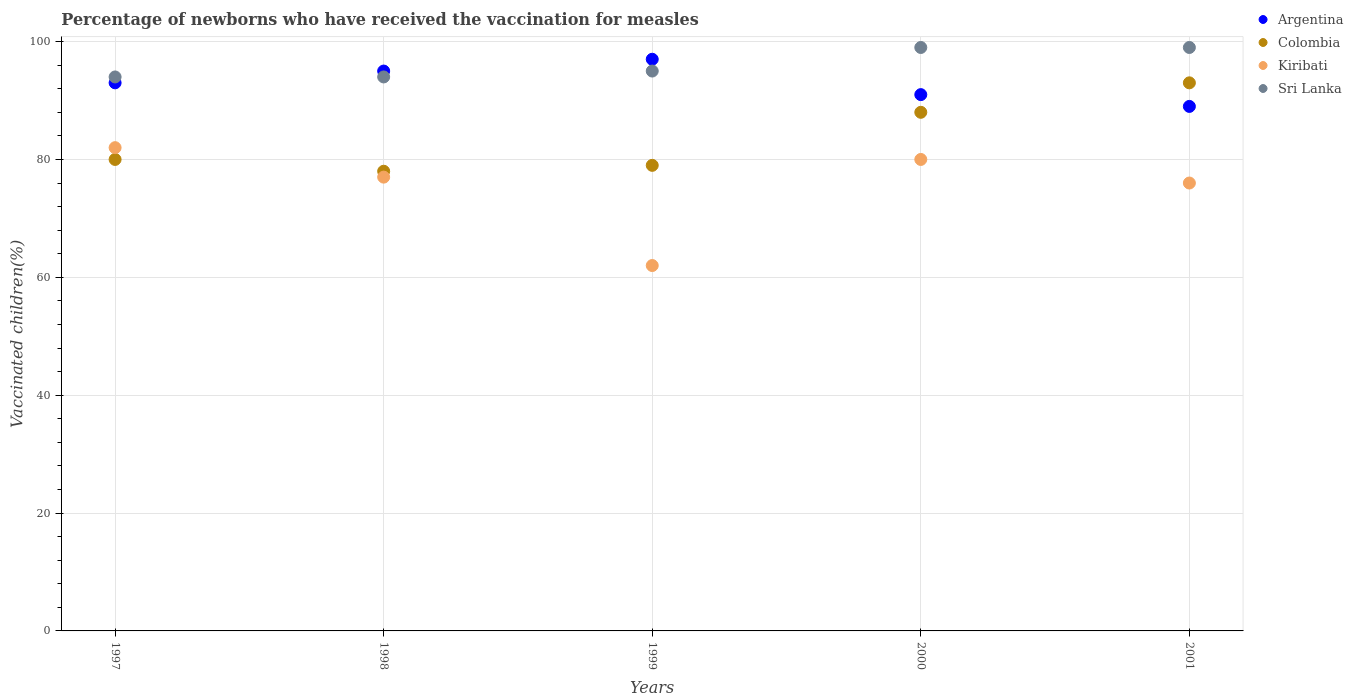What is the percentage of vaccinated children in Colombia in 2000?
Give a very brief answer. 88. Across all years, what is the maximum percentage of vaccinated children in Colombia?
Ensure brevity in your answer.  93. Across all years, what is the minimum percentage of vaccinated children in Argentina?
Make the answer very short. 89. In which year was the percentage of vaccinated children in Argentina minimum?
Offer a terse response. 2001. What is the total percentage of vaccinated children in Sri Lanka in the graph?
Keep it short and to the point. 481. What is the difference between the percentage of vaccinated children in Colombia in 1997 and that in 2001?
Your answer should be very brief. -13. What is the average percentage of vaccinated children in Sri Lanka per year?
Offer a very short reply. 96.2. In the year 2001, what is the difference between the percentage of vaccinated children in Sri Lanka and percentage of vaccinated children in Kiribati?
Offer a terse response. 23. In how many years, is the percentage of vaccinated children in Kiribati greater than 48 %?
Make the answer very short. 5. What is the ratio of the percentage of vaccinated children in Sri Lanka in 1997 to that in 1999?
Keep it short and to the point. 0.99. Is the percentage of vaccinated children in Sri Lanka in 1997 less than that in 2000?
Give a very brief answer. Yes. Is the difference between the percentage of vaccinated children in Sri Lanka in 1997 and 1998 greater than the difference between the percentage of vaccinated children in Kiribati in 1997 and 1998?
Keep it short and to the point. No. What is the difference between the highest and the lowest percentage of vaccinated children in Sri Lanka?
Your answer should be compact. 5. In how many years, is the percentage of vaccinated children in Argentina greater than the average percentage of vaccinated children in Argentina taken over all years?
Offer a very short reply. 2. Is it the case that in every year, the sum of the percentage of vaccinated children in Sri Lanka and percentage of vaccinated children in Kiribati  is greater than the sum of percentage of vaccinated children in Argentina and percentage of vaccinated children in Colombia?
Make the answer very short. No. Is it the case that in every year, the sum of the percentage of vaccinated children in Kiribati and percentage of vaccinated children in Argentina  is greater than the percentage of vaccinated children in Colombia?
Your answer should be very brief. Yes. Does the percentage of vaccinated children in Colombia monotonically increase over the years?
Give a very brief answer. No. Is the percentage of vaccinated children in Argentina strictly greater than the percentage of vaccinated children in Colombia over the years?
Provide a succinct answer. No. Is the percentage of vaccinated children in Kiribati strictly less than the percentage of vaccinated children in Argentina over the years?
Keep it short and to the point. Yes. How many years are there in the graph?
Provide a short and direct response. 5. What is the difference between two consecutive major ticks on the Y-axis?
Keep it short and to the point. 20. Does the graph contain any zero values?
Your answer should be compact. No. Does the graph contain grids?
Offer a very short reply. Yes. Where does the legend appear in the graph?
Keep it short and to the point. Top right. How many legend labels are there?
Offer a very short reply. 4. How are the legend labels stacked?
Give a very brief answer. Vertical. What is the title of the graph?
Offer a terse response. Percentage of newborns who have received the vaccination for measles. What is the label or title of the X-axis?
Offer a terse response. Years. What is the label or title of the Y-axis?
Offer a terse response. Vaccinated children(%). What is the Vaccinated children(%) of Argentina in 1997?
Keep it short and to the point. 93. What is the Vaccinated children(%) in Kiribati in 1997?
Your answer should be compact. 82. What is the Vaccinated children(%) in Sri Lanka in 1997?
Provide a succinct answer. 94. What is the Vaccinated children(%) of Sri Lanka in 1998?
Make the answer very short. 94. What is the Vaccinated children(%) in Argentina in 1999?
Provide a succinct answer. 97. What is the Vaccinated children(%) in Colombia in 1999?
Offer a very short reply. 79. What is the Vaccinated children(%) in Kiribati in 1999?
Offer a very short reply. 62. What is the Vaccinated children(%) in Sri Lanka in 1999?
Provide a short and direct response. 95. What is the Vaccinated children(%) of Argentina in 2000?
Make the answer very short. 91. What is the Vaccinated children(%) of Kiribati in 2000?
Provide a short and direct response. 80. What is the Vaccinated children(%) of Argentina in 2001?
Give a very brief answer. 89. What is the Vaccinated children(%) in Colombia in 2001?
Offer a terse response. 93. Across all years, what is the maximum Vaccinated children(%) of Argentina?
Offer a very short reply. 97. Across all years, what is the maximum Vaccinated children(%) of Colombia?
Your response must be concise. 93. Across all years, what is the maximum Vaccinated children(%) in Kiribati?
Provide a short and direct response. 82. Across all years, what is the maximum Vaccinated children(%) in Sri Lanka?
Your answer should be compact. 99. Across all years, what is the minimum Vaccinated children(%) of Argentina?
Your answer should be very brief. 89. Across all years, what is the minimum Vaccinated children(%) in Colombia?
Offer a terse response. 78. Across all years, what is the minimum Vaccinated children(%) of Kiribati?
Offer a very short reply. 62. Across all years, what is the minimum Vaccinated children(%) in Sri Lanka?
Provide a short and direct response. 94. What is the total Vaccinated children(%) in Argentina in the graph?
Your answer should be compact. 465. What is the total Vaccinated children(%) of Colombia in the graph?
Your answer should be very brief. 418. What is the total Vaccinated children(%) in Kiribati in the graph?
Offer a terse response. 377. What is the total Vaccinated children(%) in Sri Lanka in the graph?
Give a very brief answer. 481. What is the difference between the Vaccinated children(%) of Argentina in 1997 and that in 1998?
Offer a very short reply. -2. What is the difference between the Vaccinated children(%) in Colombia in 1997 and that in 1998?
Keep it short and to the point. 2. What is the difference between the Vaccinated children(%) of Kiribati in 1997 and that in 1998?
Provide a succinct answer. 5. What is the difference between the Vaccinated children(%) of Kiribati in 1997 and that in 1999?
Make the answer very short. 20. What is the difference between the Vaccinated children(%) of Sri Lanka in 1997 and that in 1999?
Offer a terse response. -1. What is the difference between the Vaccinated children(%) in Sri Lanka in 1997 and that in 2000?
Offer a terse response. -5. What is the difference between the Vaccinated children(%) in Argentina in 1997 and that in 2001?
Offer a terse response. 4. What is the difference between the Vaccinated children(%) of Colombia in 1997 and that in 2001?
Provide a short and direct response. -13. What is the difference between the Vaccinated children(%) in Kiribati in 1997 and that in 2001?
Your answer should be very brief. 6. What is the difference between the Vaccinated children(%) of Colombia in 1998 and that in 1999?
Provide a short and direct response. -1. What is the difference between the Vaccinated children(%) in Argentina in 1998 and that in 2000?
Provide a short and direct response. 4. What is the difference between the Vaccinated children(%) of Colombia in 1998 and that in 2000?
Offer a terse response. -10. What is the difference between the Vaccinated children(%) of Kiribati in 1998 and that in 2001?
Provide a succinct answer. 1. What is the difference between the Vaccinated children(%) of Argentina in 1999 and that in 2000?
Give a very brief answer. 6. What is the difference between the Vaccinated children(%) in Colombia in 1999 and that in 2000?
Your response must be concise. -9. What is the difference between the Vaccinated children(%) in Colombia in 1999 and that in 2001?
Keep it short and to the point. -14. What is the difference between the Vaccinated children(%) of Sri Lanka in 1999 and that in 2001?
Ensure brevity in your answer.  -4. What is the difference between the Vaccinated children(%) in Colombia in 2000 and that in 2001?
Keep it short and to the point. -5. What is the difference between the Vaccinated children(%) of Argentina in 1997 and the Vaccinated children(%) of Kiribati in 1998?
Provide a short and direct response. 16. What is the difference between the Vaccinated children(%) in Argentina in 1997 and the Vaccinated children(%) in Sri Lanka in 1998?
Offer a terse response. -1. What is the difference between the Vaccinated children(%) of Colombia in 1997 and the Vaccinated children(%) of Kiribati in 1998?
Your answer should be very brief. 3. What is the difference between the Vaccinated children(%) of Colombia in 1997 and the Vaccinated children(%) of Kiribati in 1999?
Make the answer very short. 18. What is the difference between the Vaccinated children(%) of Kiribati in 1997 and the Vaccinated children(%) of Sri Lanka in 1999?
Your response must be concise. -13. What is the difference between the Vaccinated children(%) in Argentina in 1997 and the Vaccinated children(%) in Colombia in 2000?
Make the answer very short. 5. What is the difference between the Vaccinated children(%) of Argentina in 1997 and the Vaccinated children(%) of Kiribati in 2000?
Keep it short and to the point. 13. What is the difference between the Vaccinated children(%) of Argentina in 1997 and the Vaccinated children(%) of Sri Lanka in 2000?
Your response must be concise. -6. What is the difference between the Vaccinated children(%) in Colombia in 1997 and the Vaccinated children(%) in Kiribati in 2000?
Keep it short and to the point. 0. What is the difference between the Vaccinated children(%) of Colombia in 1997 and the Vaccinated children(%) of Sri Lanka in 2000?
Provide a succinct answer. -19. What is the difference between the Vaccinated children(%) of Kiribati in 1997 and the Vaccinated children(%) of Sri Lanka in 2000?
Give a very brief answer. -17. What is the difference between the Vaccinated children(%) of Argentina in 1997 and the Vaccinated children(%) of Colombia in 2001?
Provide a short and direct response. 0. What is the difference between the Vaccinated children(%) in Argentina in 1998 and the Vaccinated children(%) in Sri Lanka in 1999?
Make the answer very short. 0. What is the difference between the Vaccinated children(%) in Colombia in 1998 and the Vaccinated children(%) in Kiribati in 1999?
Make the answer very short. 16. What is the difference between the Vaccinated children(%) in Kiribati in 1998 and the Vaccinated children(%) in Sri Lanka in 1999?
Ensure brevity in your answer.  -18. What is the difference between the Vaccinated children(%) in Argentina in 1998 and the Vaccinated children(%) in Colombia in 2000?
Your answer should be very brief. 7. What is the difference between the Vaccinated children(%) in Argentina in 1998 and the Vaccinated children(%) in Kiribati in 2000?
Provide a short and direct response. 15. What is the difference between the Vaccinated children(%) in Argentina in 1998 and the Vaccinated children(%) in Sri Lanka in 2001?
Give a very brief answer. -4. What is the difference between the Vaccinated children(%) of Kiribati in 1998 and the Vaccinated children(%) of Sri Lanka in 2001?
Your response must be concise. -22. What is the difference between the Vaccinated children(%) of Argentina in 1999 and the Vaccinated children(%) of Colombia in 2000?
Ensure brevity in your answer.  9. What is the difference between the Vaccinated children(%) of Argentina in 1999 and the Vaccinated children(%) of Sri Lanka in 2000?
Offer a very short reply. -2. What is the difference between the Vaccinated children(%) in Colombia in 1999 and the Vaccinated children(%) in Sri Lanka in 2000?
Offer a terse response. -20. What is the difference between the Vaccinated children(%) of Kiribati in 1999 and the Vaccinated children(%) of Sri Lanka in 2000?
Offer a terse response. -37. What is the difference between the Vaccinated children(%) in Argentina in 1999 and the Vaccinated children(%) in Colombia in 2001?
Make the answer very short. 4. What is the difference between the Vaccinated children(%) in Argentina in 1999 and the Vaccinated children(%) in Kiribati in 2001?
Provide a short and direct response. 21. What is the difference between the Vaccinated children(%) in Colombia in 1999 and the Vaccinated children(%) in Kiribati in 2001?
Provide a short and direct response. 3. What is the difference between the Vaccinated children(%) of Kiribati in 1999 and the Vaccinated children(%) of Sri Lanka in 2001?
Keep it short and to the point. -37. What is the difference between the Vaccinated children(%) in Argentina in 2000 and the Vaccinated children(%) in Kiribati in 2001?
Offer a terse response. 15. What is the difference between the Vaccinated children(%) of Argentina in 2000 and the Vaccinated children(%) of Sri Lanka in 2001?
Your answer should be very brief. -8. What is the difference between the Vaccinated children(%) of Colombia in 2000 and the Vaccinated children(%) of Kiribati in 2001?
Provide a short and direct response. 12. What is the difference between the Vaccinated children(%) in Colombia in 2000 and the Vaccinated children(%) in Sri Lanka in 2001?
Give a very brief answer. -11. What is the average Vaccinated children(%) of Argentina per year?
Ensure brevity in your answer.  93. What is the average Vaccinated children(%) of Colombia per year?
Ensure brevity in your answer.  83.6. What is the average Vaccinated children(%) in Kiribati per year?
Offer a terse response. 75.4. What is the average Vaccinated children(%) in Sri Lanka per year?
Make the answer very short. 96.2. In the year 1997, what is the difference between the Vaccinated children(%) of Argentina and Vaccinated children(%) of Colombia?
Your answer should be compact. 13. In the year 1997, what is the difference between the Vaccinated children(%) in Argentina and Vaccinated children(%) in Sri Lanka?
Your response must be concise. -1. In the year 1997, what is the difference between the Vaccinated children(%) in Colombia and Vaccinated children(%) in Sri Lanka?
Give a very brief answer. -14. In the year 1997, what is the difference between the Vaccinated children(%) of Kiribati and Vaccinated children(%) of Sri Lanka?
Offer a very short reply. -12. In the year 1998, what is the difference between the Vaccinated children(%) of Argentina and Vaccinated children(%) of Colombia?
Your answer should be compact. 17. In the year 1998, what is the difference between the Vaccinated children(%) in Argentina and Vaccinated children(%) in Kiribati?
Offer a terse response. 18. In the year 1998, what is the difference between the Vaccinated children(%) of Colombia and Vaccinated children(%) of Kiribati?
Offer a very short reply. 1. In the year 1998, what is the difference between the Vaccinated children(%) of Kiribati and Vaccinated children(%) of Sri Lanka?
Your answer should be very brief. -17. In the year 1999, what is the difference between the Vaccinated children(%) in Argentina and Vaccinated children(%) in Kiribati?
Your answer should be very brief. 35. In the year 1999, what is the difference between the Vaccinated children(%) of Kiribati and Vaccinated children(%) of Sri Lanka?
Provide a succinct answer. -33. In the year 2000, what is the difference between the Vaccinated children(%) in Argentina and Vaccinated children(%) in Colombia?
Give a very brief answer. 3. In the year 2000, what is the difference between the Vaccinated children(%) in Argentina and Vaccinated children(%) in Sri Lanka?
Provide a short and direct response. -8. In the year 2000, what is the difference between the Vaccinated children(%) of Kiribati and Vaccinated children(%) of Sri Lanka?
Keep it short and to the point. -19. In the year 2001, what is the difference between the Vaccinated children(%) in Argentina and Vaccinated children(%) in Colombia?
Offer a very short reply. -4. In the year 2001, what is the difference between the Vaccinated children(%) in Argentina and Vaccinated children(%) in Kiribati?
Your answer should be compact. 13. In the year 2001, what is the difference between the Vaccinated children(%) of Colombia and Vaccinated children(%) of Sri Lanka?
Give a very brief answer. -6. In the year 2001, what is the difference between the Vaccinated children(%) in Kiribati and Vaccinated children(%) in Sri Lanka?
Offer a very short reply. -23. What is the ratio of the Vaccinated children(%) in Argentina in 1997 to that in 1998?
Your answer should be compact. 0.98. What is the ratio of the Vaccinated children(%) in Colombia in 1997 to that in 1998?
Provide a succinct answer. 1.03. What is the ratio of the Vaccinated children(%) of Kiribati in 1997 to that in 1998?
Make the answer very short. 1.06. What is the ratio of the Vaccinated children(%) of Argentina in 1997 to that in 1999?
Your response must be concise. 0.96. What is the ratio of the Vaccinated children(%) in Colombia in 1997 to that in 1999?
Offer a very short reply. 1.01. What is the ratio of the Vaccinated children(%) of Kiribati in 1997 to that in 1999?
Offer a very short reply. 1.32. What is the ratio of the Vaccinated children(%) in Sri Lanka in 1997 to that in 1999?
Keep it short and to the point. 0.99. What is the ratio of the Vaccinated children(%) of Argentina in 1997 to that in 2000?
Ensure brevity in your answer.  1.02. What is the ratio of the Vaccinated children(%) of Kiribati in 1997 to that in 2000?
Your answer should be compact. 1.02. What is the ratio of the Vaccinated children(%) of Sri Lanka in 1997 to that in 2000?
Your response must be concise. 0.95. What is the ratio of the Vaccinated children(%) of Argentina in 1997 to that in 2001?
Your answer should be very brief. 1.04. What is the ratio of the Vaccinated children(%) of Colombia in 1997 to that in 2001?
Your answer should be very brief. 0.86. What is the ratio of the Vaccinated children(%) in Kiribati in 1997 to that in 2001?
Your answer should be compact. 1.08. What is the ratio of the Vaccinated children(%) in Sri Lanka in 1997 to that in 2001?
Make the answer very short. 0.95. What is the ratio of the Vaccinated children(%) of Argentina in 1998 to that in 1999?
Give a very brief answer. 0.98. What is the ratio of the Vaccinated children(%) in Colombia in 1998 to that in 1999?
Make the answer very short. 0.99. What is the ratio of the Vaccinated children(%) in Kiribati in 1998 to that in 1999?
Keep it short and to the point. 1.24. What is the ratio of the Vaccinated children(%) of Sri Lanka in 1998 to that in 1999?
Your answer should be very brief. 0.99. What is the ratio of the Vaccinated children(%) in Argentina in 1998 to that in 2000?
Offer a very short reply. 1.04. What is the ratio of the Vaccinated children(%) of Colombia in 1998 to that in 2000?
Make the answer very short. 0.89. What is the ratio of the Vaccinated children(%) in Kiribati in 1998 to that in 2000?
Your response must be concise. 0.96. What is the ratio of the Vaccinated children(%) in Sri Lanka in 1998 to that in 2000?
Offer a very short reply. 0.95. What is the ratio of the Vaccinated children(%) in Argentina in 1998 to that in 2001?
Keep it short and to the point. 1.07. What is the ratio of the Vaccinated children(%) in Colombia in 1998 to that in 2001?
Your response must be concise. 0.84. What is the ratio of the Vaccinated children(%) of Kiribati in 1998 to that in 2001?
Make the answer very short. 1.01. What is the ratio of the Vaccinated children(%) in Sri Lanka in 1998 to that in 2001?
Your response must be concise. 0.95. What is the ratio of the Vaccinated children(%) of Argentina in 1999 to that in 2000?
Your answer should be very brief. 1.07. What is the ratio of the Vaccinated children(%) of Colombia in 1999 to that in 2000?
Keep it short and to the point. 0.9. What is the ratio of the Vaccinated children(%) in Kiribati in 1999 to that in 2000?
Make the answer very short. 0.78. What is the ratio of the Vaccinated children(%) in Sri Lanka in 1999 to that in 2000?
Offer a terse response. 0.96. What is the ratio of the Vaccinated children(%) of Argentina in 1999 to that in 2001?
Keep it short and to the point. 1.09. What is the ratio of the Vaccinated children(%) of Colombia in 1999 to that in 2001?
Your answer should be compact. 0.85. What is the ratio of the Vaccinated children(%) of Kiribati in 1999 to that in 2001?
Keep it short and to the point. 0.82. What is the ratio of the Vaccinated children(%) of Sri Lanka in 1999 to that in 2001?
Give a very brief answer. 0.96. What is the ratio of the Vaccinated children(%) of Argentina in 2000 to that in 2001?
Your answer should be compact. 1.02. What is the ratio of the Vaccinated children(%) in Colombia in 2000 to that in 2001?
Make the answer very short. 0.95. What is the ratio of the Vaccinated children(%) of Kiribati in 2000 to that in 2001?
Your answer should be very brief. 1.05. What is the ratio of the Vaccinated children(%) in Sri Lanka in 2000 to that in 2001?
Offer a terse response. 1. What is the difference between the highest and the second highest Vaccinated children(%) in Argentina?
Your response must be concise. 2. What is the difference between the highest and the second highest Vaccinated children(%) of Sri Lanka?
Offer a terse response. 0. What is the difference between the highest and the lowest Vaccinated children(%) of Colombia?
Provide a succinct answer. 15. What is the difference between the highest and the lowest Vaccinated children(%) of Sri Lanka?
Ensure brevity in your answer.  5. 